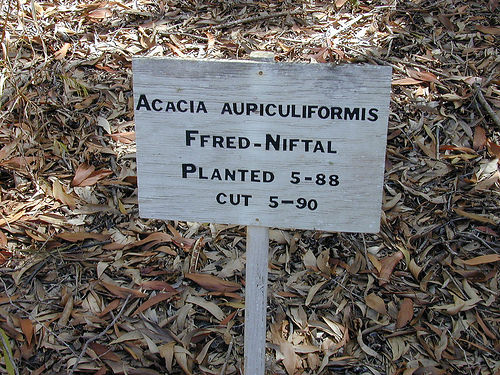<image>
Is the sign behind the leaf? No. The sign is not behind the leaf. From this viewpoint, the sign appears to be positioned elsewhere in the scene. 